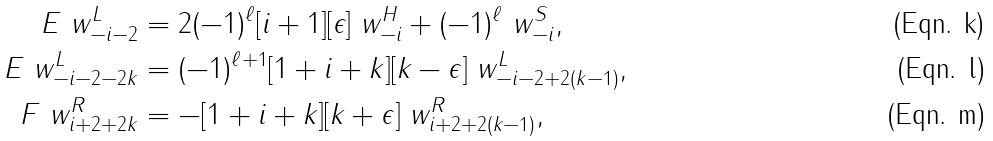<formula> <loc_0><loc_0><loc_500><loc_500>E \ w _ { - i - 2 } ^ { L } & = 2 ( - 1 ) ^ { \ell } [ i + 1 ] [ \epsilon ] \ w _ { - i } ^ { H } + ( - 1 ) ^ { \ell } \ w _ { - i } ^ { S } , \\ E \ w _ { - i - 2 - 2 k } ^ { L } & = ( - 1 ) ^ { \ell + 1 } [ 1 + i + k ] [ k - \epsilon ] \ w _ { - i - 2 + 2 ( k - 1 ) } ^ { L } , \\ F \ w _ { i + 2 + 2 k } ^ { R } & = - [ 1 + i + k ] [ k + \epsilon ] \ w _ { i + 2 + 2 ( k - 1 ) } ^ { R } ,</formula> 